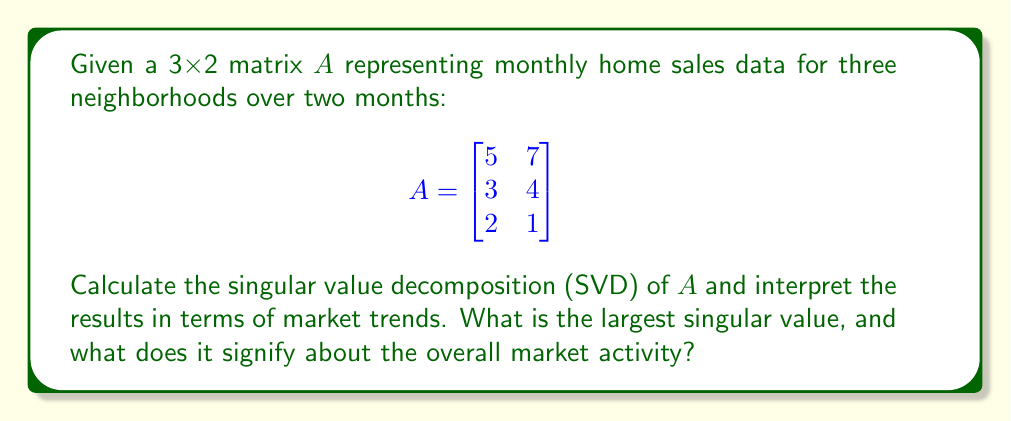Show me your answer to this math problem. To perform SVD on matrix $A$, we follow these steps:

1) First, calculate $A^TA$:
   $$A^TA = \begin{bmatrix}
   5 & 3 & 2 \\
   7 & 4 & 1
   \end{bmatrix} \begin{bmatrix}
   5 & 7 \\
   3 & 4 \\
   2 & 1
   \end{bmatrix} = \begin{bmatrix}
   38 & 50 \\
   50 & 66
   \end{bmatrix}$$

2) Find eigenvalues of $A^TA$:
   $\det(A^TA - \lambda I) = \begin{vmatrix}
   38-\lambda & 50 \\
   50 & 66-\lambda
   \end{vmatrix} = (38-\lambda)(66-\lambda) - 2500 = \lambda^2 - 104\lambda + 8 = 0$

   Solving this quadratic equation:
   $\lambda_1 \approx 102.95$ and $\lambda_2 \approx 1.05$

3) The singular values are the square roots of these eigenvalues:
   $\sigma_1 \approx \sqrt{102.95} \approx 10.15$ and $\sigma_2 \approx \sqrt{1.05} \approx 1.02$

4) The largest singular value is approximately 10.15.

Interpretation:
The largest singular value (10.15) represents the overall scale or magnitude of the market activity across all neighborhoods and months. It indicates the dominant trend in the data.

The significant difference between the two singular values (10.15 vs 1.02) suggests that there's a strong primary trend in the market, with a much weaker secondary trend.

For a new real estate broker, this means that the market is largely moving in one direction (either generally up or down) across all neighborhoods, which could be valuable information for pricing strategies and market predictions.
Answer: 10.15, indicating a strong primary market trend 